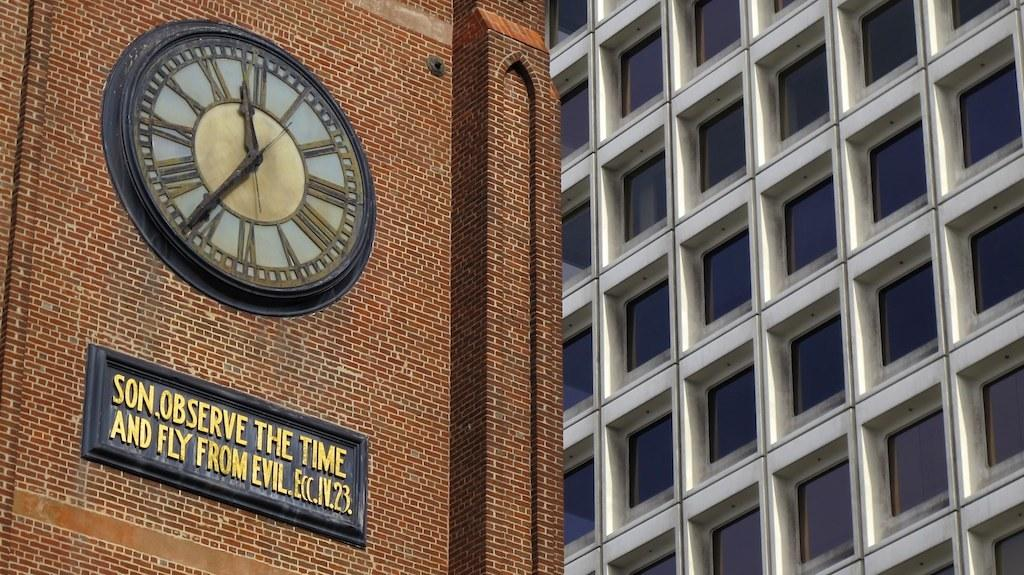<image>
Offer a succinct explanation of the picture presented. Clock on a building above some words that say "Observe the time and fly from evil". 